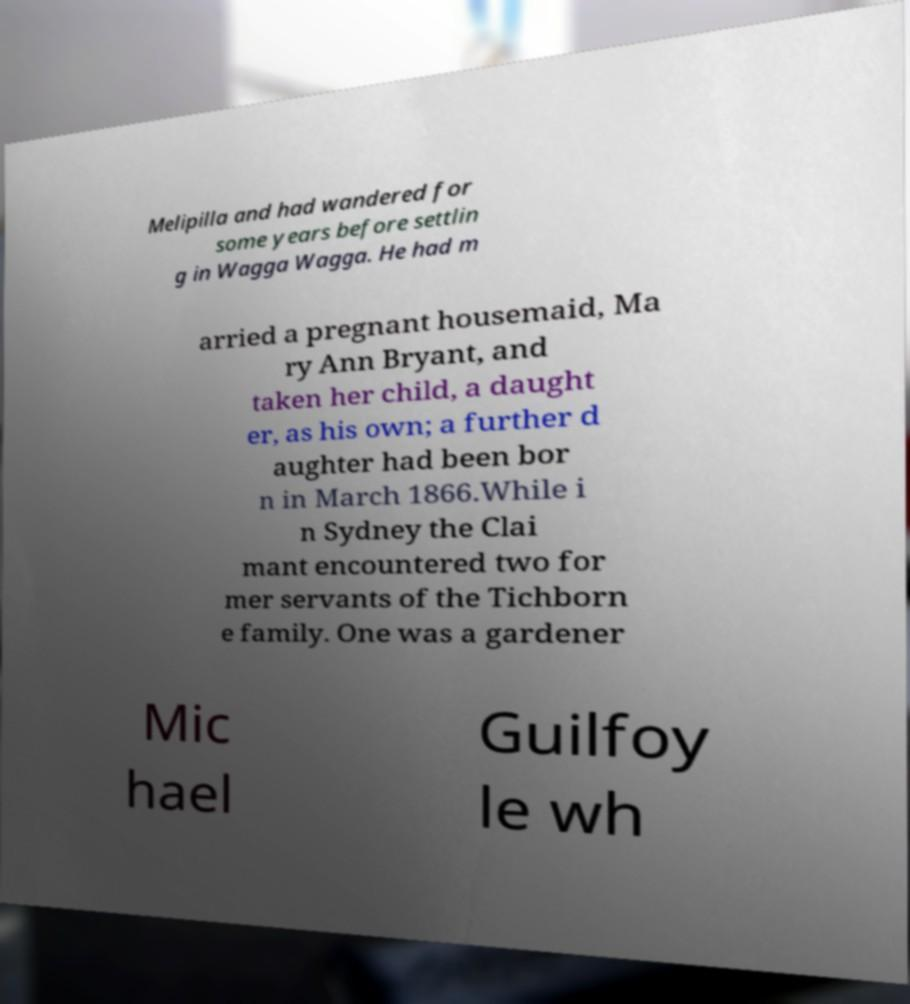For documentation purposes, I need the text within this image transcribed. Could you provide that? Melipilla and had wandered for some years before settlin g in Wagga Wagga. He had m arried a pregnant housemaid, Ma ry Ann Bryant, and taken her child, a daught er, as his own; a further d aughter had been bor n in March 1866.While i n Sydney the Clai mant encountered two for mer servants of the Tichborn e family. One was a gardener Mic hael Guilfoy le wh 